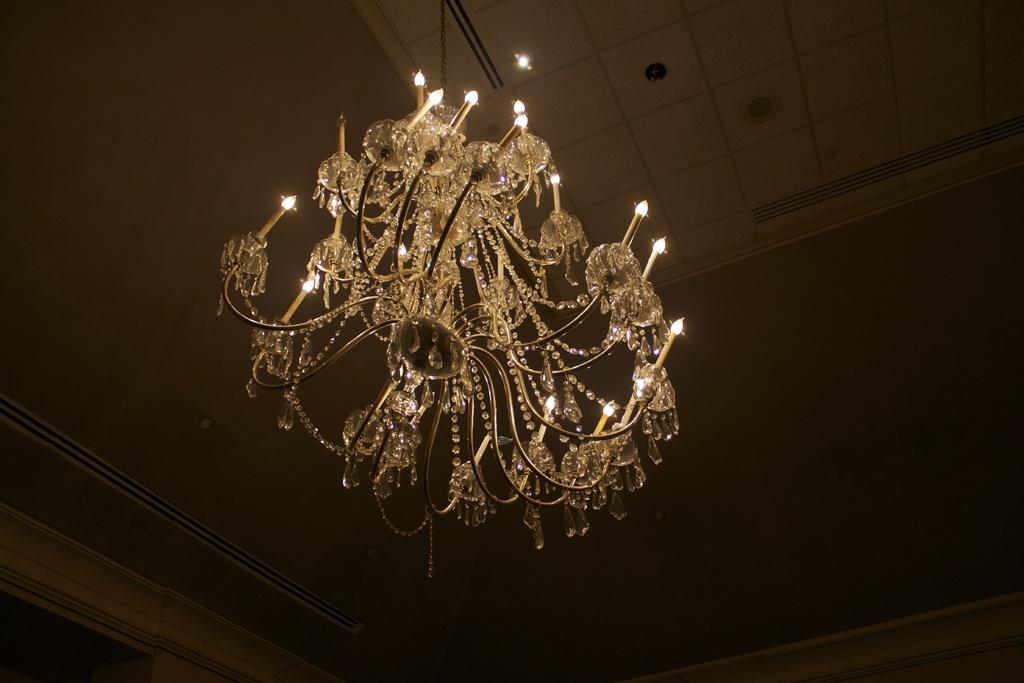What type of lighting fixture is present in the image? There is a chandelier in the image. What color is the roof in the image? The roof in the image is cream-colored. What type of account is being discussed in the image? There is no account being discussed in the image; it features a chandelier and a cream-colored roof. What religion is depicted in the image? There is no religion depicted in the image; it only shows a chandelier and a cream-colored roof. 